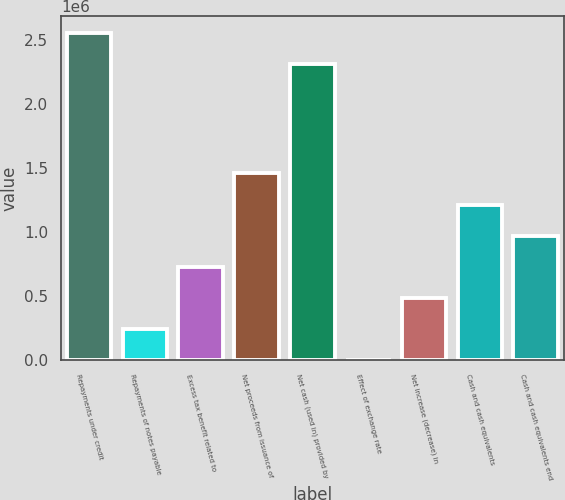Convert chart to OTSL. <chart><loc_0><loc_0><loc_500><loc_500><bar_chart><fcel>Repayments under credit<fcel>Repayments of notes payable<fcel>Excess tax benefit related to<fcel>Net proceeds from issuance of<fcel>Net cash (used in) provided by<fcel>Effect of exchange rate<fcel>Net increase (decrease) in<fcel>Cash and cash equivalents<fcel>Cash and cash equivalents end<nl><fcel>2.55348e+06<fcel>243371<fcel>728178<fcel>1.45539e+06<fcel>2.31108e+06<fcel>968<fcel>485774<fcel>1.21298e+06<fcel>970581<nl></chart> 